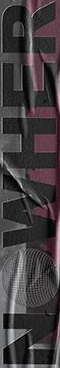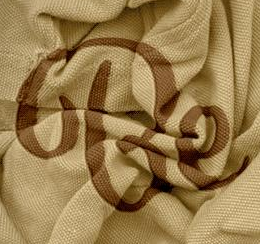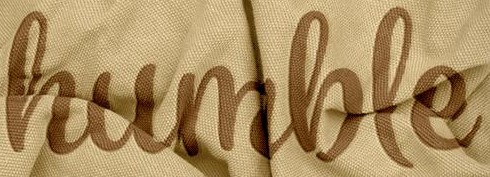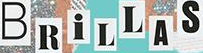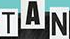What words are shown in these images in order, separated by a semicolon? NOWHER; Be; humble; BRiLLAS; TAN 